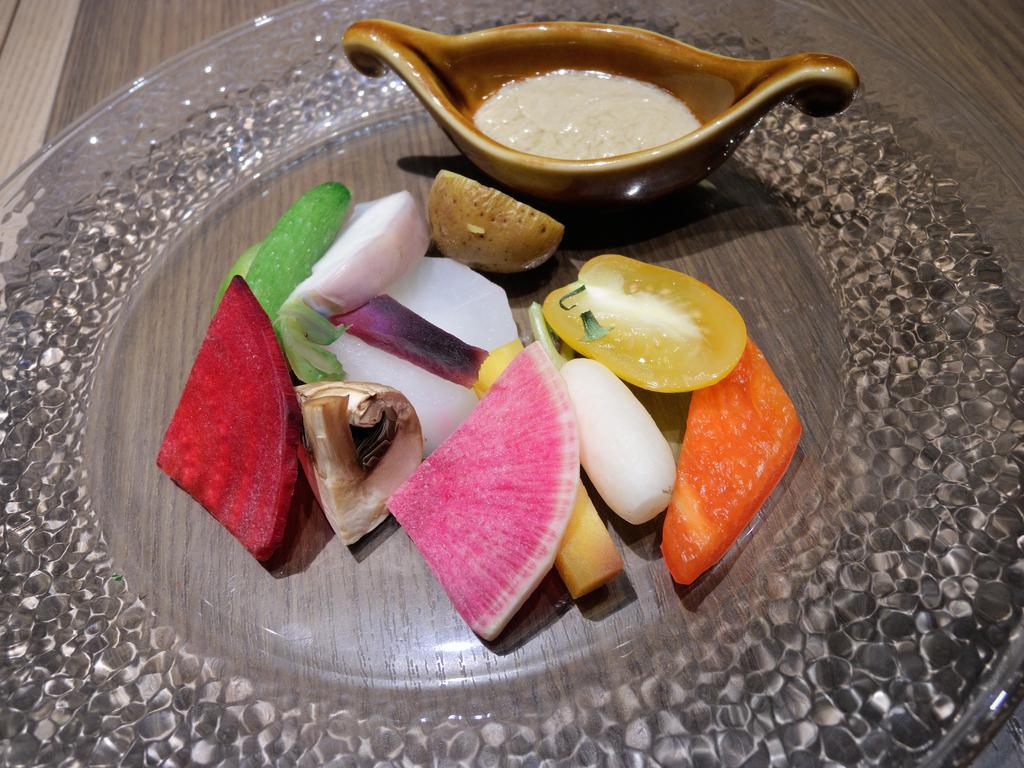Could you give a brief overview of what you see in this image? In this image, we can see a plate contains some food. There is a bowl at the top of the image. 